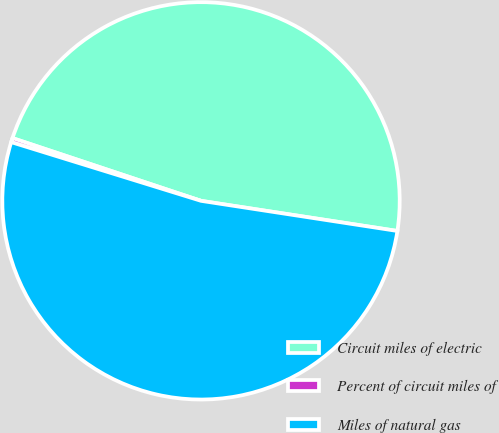<chart> <loc_0><loc_0><loc_500><loc_500><pie_chart><fcel>Circuit miles of electric<fcel>Percent of circuit miles of<fcel>Miles of natural gas<nl><fcel>47.31%<fcel>0.34%<fcel>52.35%<nl></chart> 